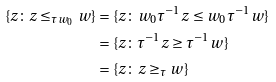<formula> <loc_0><loc_0><loc_500><loc_500>\{ z \colon z \leq _ { \tau w _ { 0 } } w \} & = \{ z \colon w _ { 0 } \tau ^ { - 1 } z \leq w _ { 0 } \tau ^ { - 1 } w \} \\ & = \{ z \colon \tau ^ { - 1 } z \geq \tau ^ { - 1 } w \} \\ & = \{ z \colon z \geq _ { \tau } w \}</formula> 